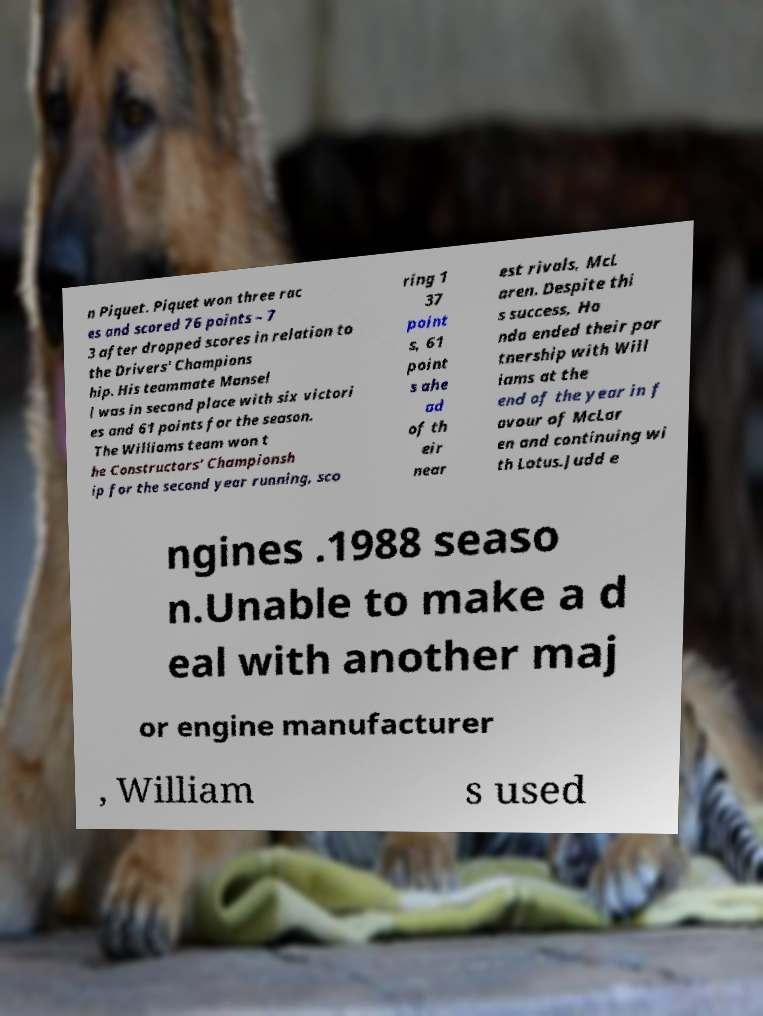Please read and relay the text visible in this image. What does it say? n Piquet. Piquet won three rac es and scored 76 points – 7 3 after dropped scores in relation to the Drivers' Champions hip. His teammate Mansel l was in second place with six victori es and 61 points for the season. The Williams team won t he Constructors' Championsh ip for the second year running, sco ring 1 37 point s, 61 point s ahe ad of th eir near est rivals, McL aren. Despite thi s success, Ho nda ended their par tnership with Will iams at the end of the year in f avour of McLar en and continuing wi th Lotus.Judd e ngines .1988 seaso n.Unable to make a d eal with another maj or engine manufacturer , William s used 